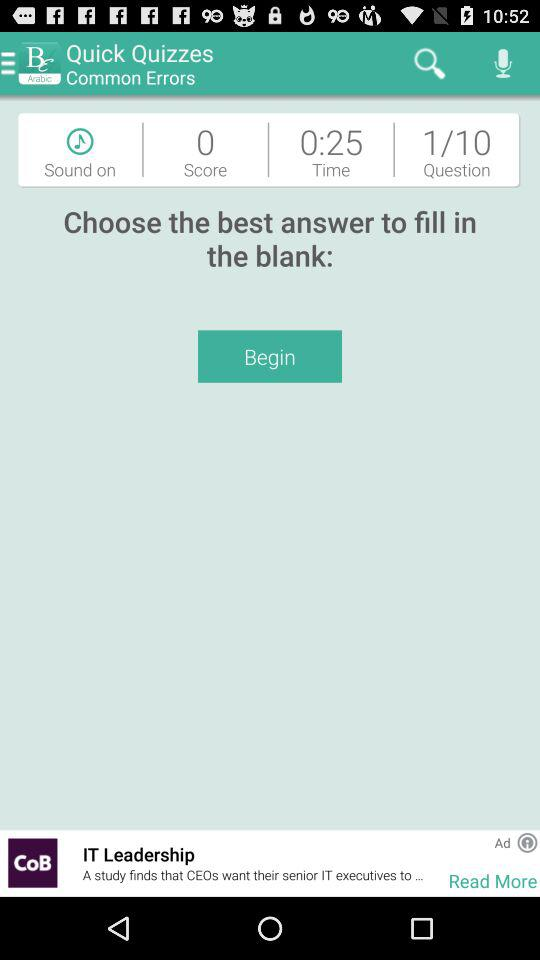How many seconds are left in the quiz?
Answer the question using a single word or phrase. 25 